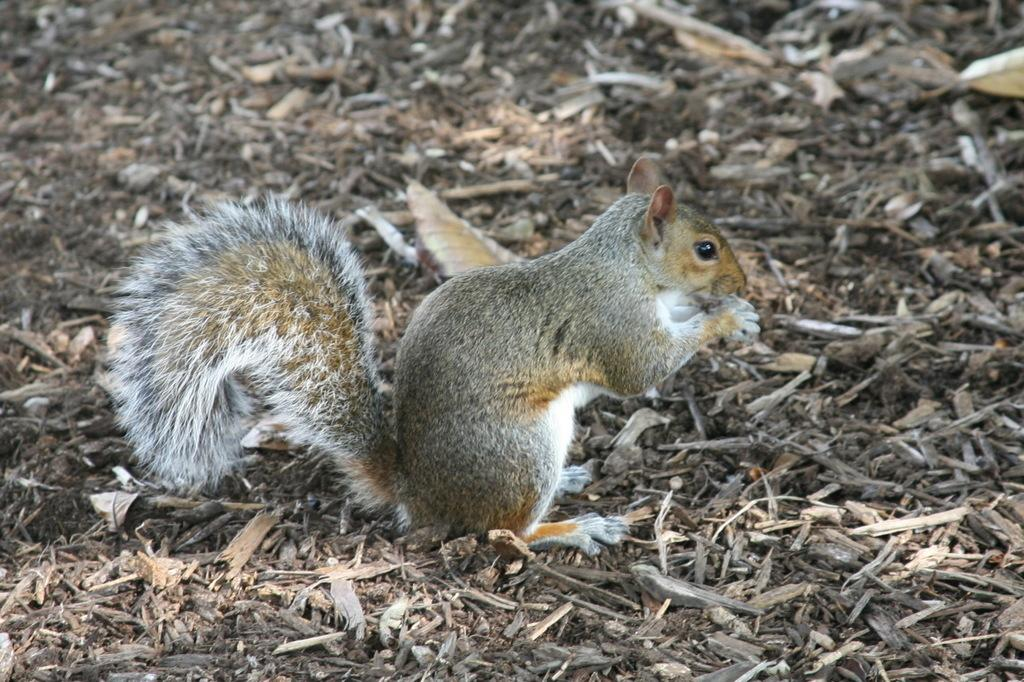What animal can be seen in the image? There is a squirrel in the image. Where is the squirrel located? The squirrel is on the ground. What colors can be observed on the squirrel? The squirrel has a white, brown, and grey coloration. What type of material is present on the ground in the image? There are wooden pieces on the ground in the image. What type of wrench is the squirrel using to fix the limit on the ghost in the image? There is no wrench, limit, or ghost present in the image; it features a squirrel on the ground with a white, brown, and grey coloration, and wooden pieces on the ground. 